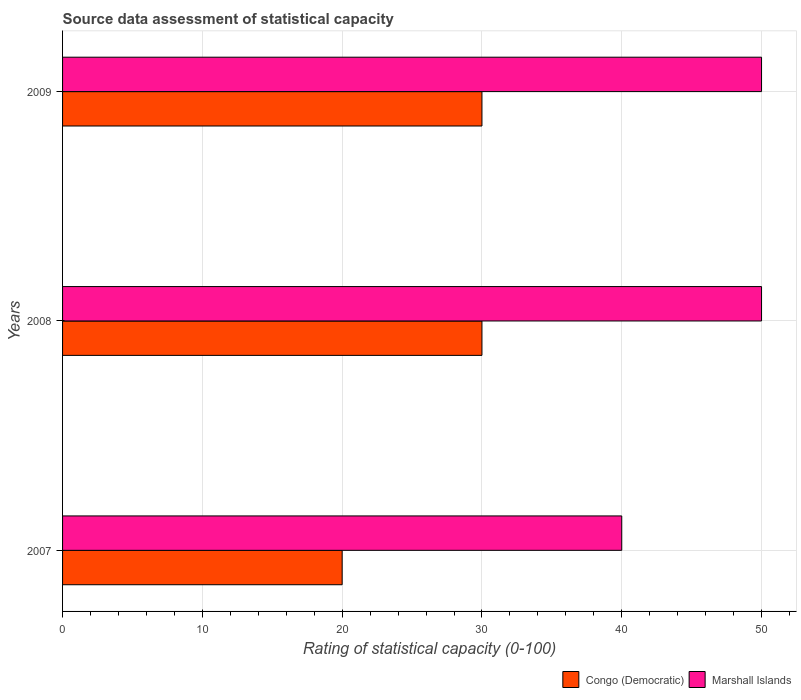How many different coloured bars are there?
Give a very brief answer. 2. How many groups of bars are there?
Give a very brief answer. 3. Are the number of bars per tick equal to the number of legend labels?
Your response must be concise. Yes. Are the number of bars on each tick of the Y-axis equal?
Your answer should be very brief. Yes. How many bars are there on the 1st tick from the top?
Give a very brief answer. 2. How many bars are there on the 1st tick from the bottom?
Give a very brief answer. 2. What is the label of the 1st group of bars from the top?
Offer a very short reply. 2009. In how many cases, is the number of bars for a given year not equal to the number of legend labels?
Keep it short and to the point. 0. What is the rating of statistical capacity in Congo (Democratic) in 2008?
Give a very brief answer. 30. Across all years, what is the maximum rating of statistical capacity in Marshall Islands?
Give a very brief answer. 50. In which year was the rating of statistical capacity in Marshall Islands maximum?
Offer a terse response. 2008. What is the total rating of statistical capacity in Congo (Democratic) in the graph?
Provide a succinct answer. 80. What is the difference between the rating of statistical capacity in Congo (Democratic) in 2007 and that in 2008?
Make the answer very short. -10. What is the average rating of statistical capacity in Congo (Democratic) per year?
Ensure brevity in your answer.  26.67. In how many years, is the rating of statistical capacity in Congo (Democratic) greater than 6 ?
Make the answer very short. 3. What is the ratio of the rating of statistical capacity in Marshall Islands in 2007 to that in 2009?
Offer a terse response. 0.8. Is the rating of statistical capacity in Marshall Islands in 2007 less than that in 2009?
Ensure brevity in your answer.  Yes. What is the difference between the highest and the second highest rating of statistical capacity in Congo (Democratic)?
Offer a terse response. 0. What is the difference between the highest and the lowest rating of statistical capacity in Congo (Democratic)?
Provide a short and direct response. 10. In how many years, is the rating of statistical capacity in Congo (Democratic) greater than the average rating of statistical capacity in Congo (Democratic) taken over all years?
Give a very brief answer. 2. Is the sum of the rating of statistical capacity in Marshall Islands in 2008 and 2009 greater than the maximum rating of statistical capacity in Congo (Democratic) across all years?
Provide a short and direct response. Yes. What does the 1st bar from the top in 2009 represents?
Provide a short and direct response. Marshall Islands. What does the 1st bar from the bottom in 2007 represents?
Offer a terse response. Congo (Democratic). How many bars are there?
Offer a very short reply. 6. How many years are there in the graph?
Make the answer very short. 3. What is the difference between two consecutive major ticks on the X-axis?
Offer a very short reply. 10. Are the values on the major ticks of X-axis written in scientific E-notation?
Ensure brevity in your answer.  No. Does the graph contain grids?
Make the answer very short. Yes. Where does the legend appear in the graph?
Keep it short and to the point. Bottom right. How many legend labels are there?
Provide a short and direct response. 2. What is the title of the graph?
Your answer should be very brief. Source data assessment of statistical capacity. Does "Libya" appear as one of the legend labels in the graph?
Keep it short and to the point. No. What is the label or title of the X-axis?
Your response must be concise. Rating of statistical capacity (0-100). Across all years, what is the maximum Rating of statistical capacity (0-100) in Marshall Islands?
Give a very brief answer. 50. What is the total Rating of statistical capacity (0-100) in Marshall Islands in the graph?
Ensure brevity in your answer.  140. What is the difference between the Rating of statistical capacity (0-100) in Marshall Islands in 2007 and that in 2008?
Provide a succinct answer. -10. What is the difference between the Rating of statistical capacity (0-100) of Congo (Democratic) in 2007 and that in 2009?
Give a very brief answer. -10. What is the difference between the Rating of statistical capacity (0-100) of Congo (Democratic) in 2008 and that in 2009?
Your response must be concise. 0. What is the difference between the Rating of statistical capacity (0-100) in Congo (Democratic) in 2007 and the Rating of statistical capacity (0-100) in Marshall Islands in 2008?
Make the answer very short. -30. What is the difference between the Rating of statistical capacity (0-100) of Congo (Democratic) in 2007 and the Rating of statistical capacity (0-100) of Marshall Islands in 2009?
Offer a terse response. -30. What is the average Rating of statistical capacity (0-100) of Congo (Democratic) per year?
Your response must be concise. 26.67. What is the average Rating of statistical capacity (0-100) in Marshall Islands per year?
Your answer should be compact. 46.67. In the year 2007, what is the difference between the Rating of statistical capacity (0-100) in Congo (Democratic) and Rating of statistical capacity (0-100) in Marshall Islands?
Offer a very short reply. -20. In the year 2008, what is the difference between the Rating of statistical capacity (0-100) in Congo (Democratic) and Rating of statistical capacity (0-100) in Marshall Islands?
Your answer should be very brief. -20. What is the ratio of the Rating of statistical capacity (0-100) of Marshall Islands in 2007 to that in 2008?
Make the answer very short. 0.8. What is the ratio of the Rating of statistical capacity (0-100) of Marshall Islands in 2007 to that in 2009?
Your answer should be very brief. 0.8. What is the ratio of the Rating of statistical capacity (0-100) of Congo (Democratic) in 2008 to that in 2009?
Your response must be concise. 1. What is the ratio of the Rating of statistical capacity (0-100) of Marshall Islands in 2008 to that in 2009?
Provide a succinct answer. 1. 